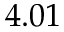<formula> <loc_0><loc_0><loc_500><loc_500>4 . 0 1</formula> 